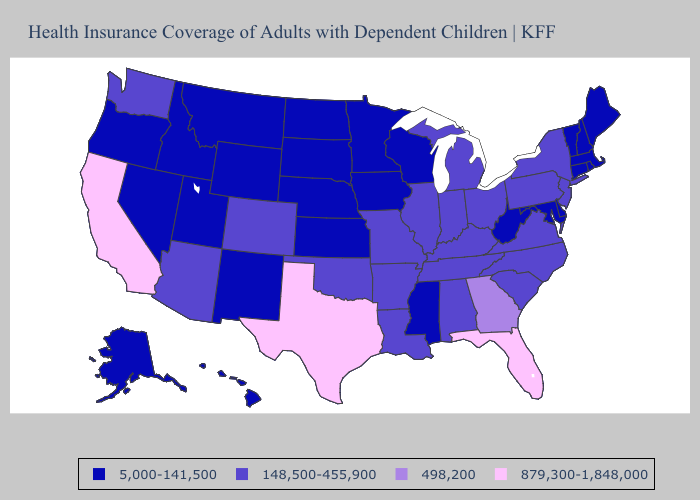Name the states that have a value in the range 879,300-1,848,000?
Keep it brief. California, Florida, Texas. Does Tennessee have the lowest value in the USA?
Give a very brief answer. No. Does Georgia have a lower value than Texas?
Write a very short answer. Yes. Does Massachusetts have the highest value in the Northeast?
Short answer required. No. What is the value of Arkansas?
Concise answer only. 148,500-455,900. Among the states that border Louisiana , which have the highest value?
Answer briefly. Texas. What is the lowest value in the USA?
Keep it brief. 5,000-141,500. Name the states that have a value in the range 148,500-455,900?
Write a very short answer. Alabama, Arizona, Arkansas, Colorado, Illinois, Indiana, Kentucky, Louisiana, Michigan, Missouri, New Jersey, New York, North Carolina, Ohio, Oklahoma, Pennsylvania, South Carolina, Tennessee, Virginia, Washington. Name the states that have a value in the range 879,300-1,848,000?
Concise answer only. California, Florida, Texas. Which states have the lowest value in the South?
Concise answer only. Delaware, Maryland, Mississippi, West Virginia. What is the value of Massachusetts?
Keep it brief. 5,000-141,500. Does the map have missing data?
Keep it brief. No. Which states have the highest value in the USA?
Be succinct. California, Florida, Texas. Does the map have missing data?
Keep it brief. No. Name the states that have a value in the range 5,000-141,500?
Write a very short answer. Alaska, Connecticut, Delaware, Hawaii, Idaho, Iowa, Kansas, Maine, Maryland, Massachusetts, Minnesota, Mississippi, Montana, Nebraska, Nevada, New Hampshire, New Mexico, North Dakota, Oregon, Rhode Island, South Dakota, Utah, Vermont, West Virginia, Wisconsin, Wyoming. 